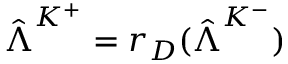Convert formula to latex. <formula><loc_0><loc_0><loc_500><loc_500>\hat { \Lambda } ^ { K ^ { + } } = r _ { D } ( \hat { \Lambda } ^ { K ^ { - } } )</formula> 